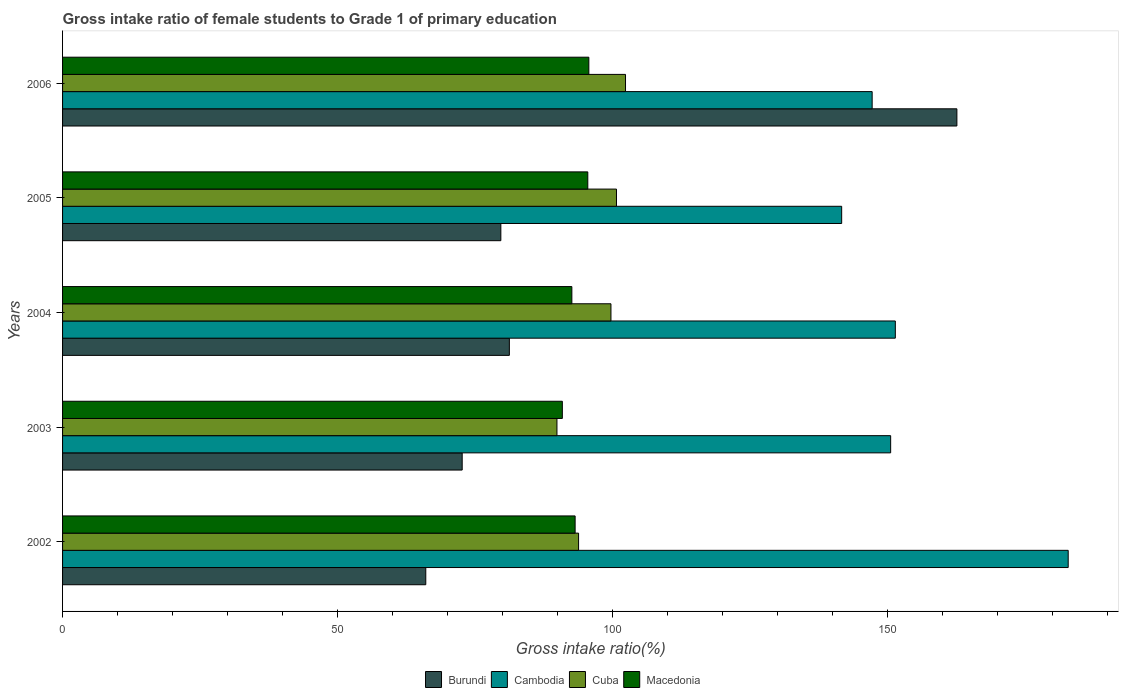How many different coloured bars are there?
Your response must be concise. 4. Are the number of bars per tick equal to the number of legend labels?
Ensure brevity in your answer.  Yes. Are the number of bars on each tick of the Y-axis equal?
Provide a succinct answer. Yes. How many bars are there on the 3rd tick from the top?
Make the answer very short. 4. In how many cases, is the number of bars for a given year not equal to the number of legend labels?
Give a very brief answer. 0. What is the gross intake ratio in Macedonia in 2004?
Keep it short and to the point. 92.58. Across all years, what is the maximum gross intake ratio in Macedonia?
Make the answer very short. 95.67. Across all years, what is the minimum gross intake ratio in Cambodia?
Ensure brevity in your answer.  141.63. In which year was the gross intake ratio in Macedonia maximum?
Give a very brief answer. 2006. What is the total gross intake ratio in Cambodia in the graph?
Ensure brevity in your answer.  773.53. What is the difference between the gross intake ratio in Cambodia in 2004 and that in 2005?
Give a very brief answer. 9.75. What is the difference between the gross intake ratio in Cambodia in 2005 and the gross intake ratio in Burundi in 2002?
Give a very brief answer. 75.6. What is the average gross intake ratio in Cambodia per year?
Offer a terse response. 154.71. In the year 2006, what is the difference between the gross intake ratio in Cuba and gross intake ratio in Macedonia?
Your answer should be very brief. 6.67. What is the ratio of the gross intake ratio in Cambodia in 2003 to that in 2006?
Your answer should be very brief. 1.02. Is the difference between the gross intake ratio in Cuba in 2004 and 2005 greater than the difference between the gross intake ratio in Macedonia in 2004 and 2005?
Offer a very short reply. Yes. What is the difference between the highest and the second highest gross intake ratio in Macedonia?
Your answer should be very brief. 0.19. What is the difference between the highest and the lowest gross intake ratio in Burundi?
Your answer should be very brief. 96.55. Is it the case that in every year, the sum of the gross intake ratio in Cambodia and gross intake ratio in Cuba is greater than the sum of gross intake ratio in Macedonia and gross intake ratio in Burundi?
Offer a very short reply. Yes. What does the 2nd bar from the top in 2006 represents?
Keep it short and to the point. Cuba. What does the 2nd bar from the bottom in 2006 represents?
Give a very brief answer. Cambodia. How many bars are there?
Your answer should be very brief. 20. How many years are there in the graph?
Provide a succinct answer. 5. Are the values on the major ticks of X-axis written in scientific E-notation?
Keep it short and to the point. No. Does the graph contain grids?
Make the answer very short. No. How are the legend labels stacked?
Make the answer very short. Horizontal. What is the title of the graph?
Keep it short and to the point. Gross intake ratio of female students to Grade 1 of primary education. Does "Macedonia" appear as one of the legend labels in the graph?
Keep it short and to the point. Yes. What is the label or title of the X-axis?
Provide a succinct answer. Gross intake ratio(%). What is the label or title of the Y-axis?
Make the answer very short. Years. What is the Gross intake ratio(%) in Burundi in 2002?
Offer a very short reply. 66.03. What is the Gross intake ratio(%) in Cambodia in 2002?
Give a very brief answer. 182.81. What is the Gross intake ratio(%) of Cuba in 2002?
Keep it short and to the point. 93.8. What is the Gross intake ratio(%) of Macedonia in 2002?
Provide a succinct answer. 93.17. What is the Gross intake ratio(%) in Burundi in 2003?
Provide a short and direct response. 72.65. What is the Gross intake ratio(%) in Cambodia in 2003?
Keep it short and to the point. 150.54. What is the Gross intake ratio(%) of Cuba in 2003?
Provide a short and direct response. 89.87. What is the Gross intake ratio(%) in Macedonia in 2003?
Your answer should be very brief. 90.85. What is the Gross intake ratio(%) of Burundi in 2004?
Your answer should be very brief. 81.22. What is the Gross intake ratio(%) in Cambodia in 2004?
Provide a short and direct response. 151.38. What is the Gross intake ratio(%) in Cuba in 2004?
Your answer should be compact. 99.69. What is the Gross intake ratio(%) in Macedonia in 2004?
Make the answer very short. 92.58. What is the Gross intake ratio(%) of Burundi in 2005?
Provide a succinct answer. 79.67. What is the Gross intake ratio(%) in Cambodia in 2005?
Offer a very short reply. 141.63. What is the Gross intake ratio(%) in Cuba in 2005?
Make the answer very short. 100.69. What is the Gross intake ratio(%) in Macedonia in 2005?
Provide a succinct answer. 95.48. What is the Gross intake ratio(%) in Burundi in 2006?
Provide a short and direct response. 162.58. What is the Gross intake ratio(%) in Cambodia in 2006?
Your response must be concise. 147.17. What is the Gross intake ratio(%) in Cuba in 2006?
Provide a succinct answer. 102.34. What is the Gross intake ratio(%) in Macedonia in 2006?
Your answer should be compact. 95.67. Across all years, what is the maximum Gross intake ratio(%) of Burundi?
Make the answer very short. 162.58. Across all years, what is the maximum Gross intake ratio(%) of Cambodia?
Keep it short and to the point. 182.81. Across all years, what is the maximum Gross intake ratio(%) of Cuba?
Provide a short and direct response. 102.34. Across all years, what is the maximum Gross intake ratio(%) in Macedonia?
Offer a terse response. 95.67. Across all years, what is the minimum Gross intake ratio(%) in Burundi?
Your answer should be compact. 66.03. Across all years, what is the minimum Gross intake ratio(%) of Cambodia?
Keep it short and to the point. 141.63. Across all years, what is the minimum Gross intake ratio(%) in Cuba?
Provide a short and direct response. 89.87. Across all years, what is the minimum Gross intake ratio(%) in Macedonia?
Keep it short and to the point. 90.85. What is the total Gross intake ratio(%) in Burundi in the graph?
Your response must be concise. 462.14. What is the total Gross intake ratio(%) of Cambodia in the graph?
Keep it short and to the point. 773.53. What is the total Gross intake ratio(%) of Cuba in the graph?
Your answer should be compact. 486.4. What is the total Gross intake ratio(%) of Macedonia in the graph?
Keep it short and to the point. 467.76. What is the difference between the Gross intake ratio(%) in Burundi in 2002 and that in 2003?
Your answer should be very brief. -6.62. What is the difference between the Gross intake ratio(%) of Cambodia in 2002 and that in 2003?
Ensure brevity in your answer.  32.28. What is the difference between the Gross intake ratio(%) in Cuba in 2002 and that in 2003?
Your answer should be very brief. 3.93. What is the difference between the Gross intake ratio(%) of Macedonia in 2002 and that in 2003?
Your response must be concise. 2.32. What is the difference between the Gross intake ratio(%) in Burundi in 2002 and that in 2004?
Offer a terse response. -15.19. What is the difference between the Gross intake ratio(%) of Cambodia in 2002 and that in 2004?
Provide a short and direct response. 31.43. What is the difference between the Gross intake ratio(%) in Cuba in 2002 and that in 2004?
Provide a succinct answer. -5.89. What is the difference between the Gross intake ratio(%) in Macedonia in 2002 and that in 2004?
Give a very brief answer. 0.59. What is the difference between the Gross intake ratio(%) in Burundi in 2002 and that in 2005?
Make the answer very short. -13.65. What is the difference between the Gross intake ratio(%) in Cambodia in 2002 and that in 2005?
Your answer should be compact. 41.18. What is the difference between the Gross intake ratio(%) of Cuba in 2002 and that in 2005?
Keep it short and to the point. -6.89. What is the difference between the Gross intake ratio(%) of Macedonia in 2002 and that in 2005?
Provide a short and direct response. -2.3. What is the difference between the Gross intake ratio(%) of Burundi in 2002 and that in 2006?
Make the answer very short. -96.55. What is the difference between the Gross intake ratio(%) in Cambodia in 2002 and that in 2006?
Provide a succinct answer. 35.64. What is the difference between the Gross intake ratio(%) of Cuba in 2002 and that in 2006?
Offer a terse response. -8.53. What is the difference between the Gross intake ratio(%) in Macedonia in 2002 and that in 2006?
Make the answer very short. -2.5. What is the difference between the Gross intake ratio(%) of Burundi in 2003 and that in 2004?
Your response must be concise. -8.57. What is the difference between the Gross intake ratio(%) of Cambodia in 2003 and that in 2004?
Your answer should be compact. -0.85. What is the difference between the Gross intake ratio(%) of Cuba in 2003 and that in 2004?
Keep it short and to the point. -9.82. What is the difference between the Gross intake ratio(%) of Macedonia in 2003 and that in 2004?
Ensure brevity in your answer.  -1.73. What is the difference between the Gross intake ratio(%) of Burundi in 2003 and that in 2005?
Provide a short and direct response. -7.03. What is the difference between the Gross intake ratio(%) of Cambodia in 2003 and that in 2005?
Provide a short and direct response. 8.9. What is the difference between the Gross intake ratio(%) in Cuba in 2003 and that in 2005?
Give a very brief answer. -10.82. What is the difference between the Gross intake ratio(%) in Macedonia in 2003 and that in 2005?
Provide a succinct answer. -4.63. What is the difference between the Gross intake ratio(%) of Burundi in 2003 and that in 2006?
Make the answer very short. -89.93. What is the difference between the Gross intake ratio(%) of Cambodia in 2003 and that in 2006?
Give a very brief answer. 3.36. What is the difference between the Gross intake ratio(%) of Cuba in 2003 and that in 2006?
Your answer should be compact. -12.46. What is the difference between the Gross intake ratio(%) in Macedonia in 2003 and that in 2006?
Offer a terse response. -4.82. What is the difference between the Gross intake ratio(%) of Burundi in 2004 and that in 2005?
Provide a succinct answer. 1.55. What is the difference between the Gross intake ratio(%) in Cambodia in 2004 and that in 2005?
Give a very brief answer. 9.75. What is the difference between the Gross intake ratio(%) in Cuba in 2004 and that in 2005?
Give a very brief answer. -1. What is the difference between the Gross intake ratio(%) of Macedonia in 2004 and that in 2005?
Keep it short and to the point. -2.9. What is the difference between the Gross intake ratio(%) of Burundi in 2004 and that in 2006?
Keep it short and to the point. -81.36. What is the difference between the Gross intake ratio(%) in Cambodia in 2004 and that in 2006?
Ensure brevity in your answer.  4.21. What is the difference between the Gross intake ratio(%) in Cuba in 2004 and that in 2006?
Keep it short and to the point. -2.65. What is the difference between the Gross intake ratio(%) of Macedonia in 2004 and that in 2006?
Your answer should be compact. -3.09. What is the difference between the Gross intake ratio(%) of Burundi in 2005 and that in 2006?
Provide a succinct answer. -82.9. What is the difference between the Gross intake ratio(%) of Cambodia in 2005 and that in 2006?
Offer a very short reply. -5.54. What is the difference between the Gross intake ratio(%) in Cuba in 2005 and that in 2006?
Your response must be concise. -1.64. What is the difference between the Gross intake ratio(%) in Macedonia in 2005 and that in 2006?
Ensure brevity in your answer.  -0.19. What is the difference between the Gross intake ratio(%) of Burundi in 2002 and the Gross intake ratio(%) of Cambodia in 2003?
Provide a succinct answer. -84.51. What is the difference between the Gross intake ratio(%) in Burundi in 2002 and the Gross intake ratio(%) in Cuba in 2003?
Your response must be concise. -23.85. What is the difference between the Gross intake ratio(%) of Burundi in 2002 and the Gross intake ratio(%) of Macedonia in 2003?
Offer a terse response. -24.83. What is the difference between the Gross intake ratio(%) in Cambodia in 2002 and the Gross intake ratio(%) in Cuba in 2003?
Your answer should be compact. 92.94. What is the difference between the Gross intake ratio(%) in Cambodia in 2002 and the Gross intake ratio(%) in Macedonia in 2003?
Your response must be concise. 91.96. What is the difference between the Gross intake ratio(%) in Cuba in 2002 and the Gross intake ratio(%) in Macedonia in 2003?
Your answer should be compact. 2.95. What is the difference between the Gross intake ratio(%) of Burundi in 2002 and the Gross intake ratio(%) of Cambodia in 2004?
Provide a short and direct response. -85.36. What is the difference between the Gross intake ratio(%) of Burundi in 2002 and the Gross intake ratio(%) of Cuba in 2004?
Provide a succinct answer. -33.66. What is the difference between the Gross intake ratio(%) of Burundi in 2002 and the Gross intake ratio(%) of Macedonia in 2004?
Make the answer very short. -26.55. What is the difference between the Gross intake ratio(%) of Cambodia in 2002 and the Gross intake ratio(%) of Cuba in 2004?
Offer a very short reply. 83.12. What is the difference between the Gross intake ratio(%) of Cambodia in 2002 and the Gross intake ratio(%) of Macedonia in 2004?
Provide a succinct answer. 90.23. What is the difference between the Gross intake ratio(%) in Cuba in 2002 and the Gross intake ratio(%) in Macedonia in 2004?
Offer a terse response. 1.22. What is the difference between the Gross intake ratio(%) in Burundi in 2002 and the Gross intake ratio(%) in Cambodia in 2005?
Provide a succinct answer. -75.6. What is the difference between the Gross intake ratio(%) in Burundi in 2002 and the Gross intake ratio(%) in Cuba in 2005?
Keep it short and to the point. -34.67. What is the difference between the Gross intake ratio(%) of Burundi in 2002 and the Gross intake ratio(%) of Macedonia in 2005?
Give a very brief answer. -29.45. What is the difference between the Gross intake ratio(%) in Cambodia in 2002 and the Gross intake ratio(%) in Cuba in 2005?
Your response must be concise. 82.12. What is the difference between the Gross intake ratio(%) of Cambodia in 2002 and the Gross intake ratio(%) of Macedonia in 2005?
Your response must be concise. 87.33. What is the difference between the Gross intake ratio(%) of Cuba in 2002 and the Gross intake ratio(%) of Macedonia in 2005?
Keep it short and to the point. -1.67. What is the difference between the Gross intake ratio(%) of Burundi in 2002 and the Gross intake ratio(%) of Cambodia in 2006?
Give a very brief answer. -81.15. What is the difference between the Gross intake ratio(%) in Burundi in 2002 and the Gross intake ratio(%) in Cuba in 2006?
Make the answer very short. -36.31. What is the difference between the Gross intake ratio(%) in Burundi in 2002 and the Gross intake ratio(%) in Macedonia in 2006?
Provide a short and direct response. -29.64. What is the difference between the Gross intake ratio(%) in Cambodia in 2002 and the Gross intake ratio(%) in Cuba in 2006?
Provide a succinct answer. 80.47. What is the difference between the Gross intake ratio(%) of Cambodia in 2002 and the Gross intake ratio(%) of Macedonia in 2006?
Your response must be concise. 87.14. What is the difference between the Gross intake ratio(%) of Cuba in 2002 and the Gross intake ratio(%) of Macedonia in 2006?
Keep it short and to the point. -1.87. What is the difference between the Gross intake ratio(%) in Burundi in 2003 and the Gross intake ratio(%) in Cambodia in 2004?
Offer a very short reply. -78.74. What is the difference between the Gross intake ratio(%) in Burundi in 2003 and the Gross intake ratio(%) in Cuba in 2004?
Make the answer very short. -27.04. What is the difference between the Gross intake ratio(%) in Burundi in 2003 and the Gross intake ratio(%) in Macedonia in 2004?
Keep it short and to the point. -19.94. What is the difference between the Gross intake ratio(%) of Cambodia in 2003 and the Gross intake ratio(%) of Cuba in 2004?
Give a very brief answer. 50.85. What is the difference between the Gross intake ratio(%) of Cambodia in 2003 and the Gross intake ratio(%) of Macedonia in 2004?
Give a very brief answer. 57.96. What is the difference between the Gross intake ratio(%) in Cuba in 2003 and the Gross intake ratio(%) in Macedonia in 2004?
Your response must be concise. -2.71. What is the difference between the Gross intake ratio(%) of Burundi in 2003 and the Gross intake ratio(%) of Cambodia in 2005?
Offer a terse response. -68.99. What is the difference between the Gross intake ratio(%) of Burundi in 2003 and the Gross intake ratio(%) of Cuba in 2005?
Offer a very short reply. -28.05. What is the difference between the Gross intake ratio(%) of Burundi in 2003 and the Gross intake ratio(%) of Macedonia in 2005?
Offer a terse response. -22.83. What is the difference between the Gross intake ratio(%) in Cambodia in 2003 and the Gross intake ratio(%) in Cuba in 2005?
Ensure brevity in your answer.  49.84. What is the difference between the Gross intake ratio(%) in Cambodia in 2003 and the Gross intake ratio(%) in Macedonia in 2005?
Offer a very short reply. 55.06. What is the difference between the Gross intake ratio(%) in Cuba in 2003 and the Gross intake ratio(%) in Macedonia in 2005?
Your answer should be very brief. -5.61. What is the difference between the Gross intake ratio(%) of Burundi in 2003 and the Gross intake ratio(%) of Cambodia in 2006?
Provide a short and direct response. -74.53. What is the difference between the Gross intake ratio(%) of Burundi in 2003 and the Gross intake ratio(%) of Cuba in 2006?
Provide a succinct answer. -29.69. What is the difference between the Gross intake ratio(%) in Burundi in 2003 and the Gross intake ratio(%) in Macedonia in 2006?
Your answer should be very brief. -23.02. What is the difference between the Gross intake ratio(%) of Cambodia in 2003 and the Gross intake ratio(%) of Cuba in 2006?
Your response must be concise. 48.2. What is the difference between the Gross intake ratio(%) in Cambodia in 2003 and the Gross intake ratio(%) in Macedonia in 2006?
Offer a very short reply. 54.87. What is the difference between the Gross intake ratio(%) in Cuba in 2003 and the Gross intake ratio(%) in Macedonia in 2006?
Your response must be concise. -5.8. What is the difference between the Gross intake ratio(%) in Burundi in 2004 and the Gross intake ratio(%) in Cambodia in 2005?
Your answer should be compact. -60.41. What is the difference between the Gross intake ratio(%) in Burundi in 2004 and the Gross intake ratio(%) in Cuba in 2005?
Give a very brief answer. -19.48. What is the difference between the Gross intake ratio(%) in Burundi in 2004 and the Gross intake ratio(%) in Macedonia in 2005?
Offer a terse response. -14.26. What is the difference between the Gross intake ratio(%) of Cambodia in 2004 and the Gross intake ratio(%) of Cuba in 2005?
Give a very brief answer. 50.69. What is the difference between the Gross intake ratio(%) of Cambodia in 2004 and the Gross intake ratio(%) of Macedonia in 2005?
Offer a very short reply. 55.9. What is the difference between the Gross intake ratio(%) in Cuba in 2004 and the Gross intake ratio(%) in Macedonia in 2005?
Offer a terse response. 4.21. What is the difference between the Gross intake ratio(%) in Burundi in 2004 and the Gross intake ratio(%) in Cambodia in 2006?
Give a very brief answer. -65.95. What is the difference between the Gross intake ratio(%) of Burundi in 2004 and the Gross intake ratio(%) of Cuba in 2006?
Your answer should be compact. -21.12. What is the difference between the Gross intake ratio(%) in Burundi in 2004 and the Gross intake ratio(%) in Macedonia in 2006?
Offer a very short reply. -14.45. What is the difference between the Gross intake ratio(%) of Cambodia in 2004 and the Gross intake ratio(%) of Cuba in 2006?
Keep it short and to the point. 49.05. What is the difference between the Gross intake ratio(%) in Cambodia in 2004 and the Gross intake ratio(%) in Macedonia in 2006?
Your response must be concise. 55.71. What is the difference between the Gross intake ratio(%) of Cuba in 2004 and the Gross intake ratio(%) of Macedonia in 2006?
Ensure brevity in your answer.  4.02. What is the difference between the Gross intake ratio(%) of Burundi in 2005 and the Gross intake ratio(%) of Cambodia in 2006?
Provide a short and direct response. -67.5. What is the difference between the Gross intake ratio(%) of Burundi in 2005 and the Gross intake ratio(%) of Cuba in 2006?
Give a very brief answer. -22.66. What is the difference between the Gross intake ratio(%) in Burundi in 2005 and the Gross intake ratio(%) in Macedonia in 2006?
Offer a terse response. -16. What is the difference between the Gross intake ratio(%) in Cambodia in 2005 and the Gross intake ratio(%) in Cuba in 2006?
Give a very brief answer. 39.29. What is the difference between the Gross intake ratio(%) of Cambodia in 2005 and the Gross intake ratio(%) of Macedonia in 2006?
Give a very brief answer. 45.96. What is the difference between the Gross intake ratio(%) in Cuba in 2005 and the Gross intake ratio(%) in Macedonia in 2006?
Offer a very short reply. 5.02. What is the average Gross intake ratio(%) in Burundi per year?
Offer a very short reply. 92.43. What is the average Gross intake ratio(%) of Cambodia per year?
Your answer should be very brief. 154.71. What is the average Gross intake ratio(%) in Cuba per year?
Keep it short and to the point. 97.28. What is the average Gross intake ratio(%) in Macedonia per year?
Give a very brief answer. 93.55. In the year 2002, what is the difference between the Gross intake ratio(%) in Burundi and Gross intake ratio(%) in Cambodia?
Your answer should be compact. -116.78. In the year 2002, what is the difference between the Gross intake ratio(%) of Burundi and Gross intake ratio(%) of Cuba?
Provide a short and direct response. -27.78. In the year 2002, what is the difference between the Gross intake ratio(%) in Burundi and Gross intake ratio(%) in Macedonia?
Keep it short and to the point. -27.15. In the year 2002, what is the difference between the Gross intake ratio(%) in Cambodia and Gross intake ratio(%) in Cuba?
Ensure brevity in your answer.  89.01. In the year 2002, what is the difference between the Gross intake ratio(%) in Cambodia and Gross intake ratio(%) in Macedonia?
Provide a short and direct response. 89.64. In the year 2002, what is the difference between the Gross intake ratio(%) in Cuba and Gross intake ratio(%) in Macedonia?
Ensure brevity in your answer.  0.63. In the year 2003, what is the difference between the Gross intake ratio(%) of Burundi and Gross intake ratio(%) of Cambodia?
Keep it short and to the point. -77.89. In the year 2003, what is the difference between the Gross intake ratio(%) of Burundi and Gross intake ratio(%) of Cuba?
Make the answer very short. -17.23. In the year 2003, what is the difference between the Gross intake ratio(%) in Burundi and Gross intake ratio(%) in Macedonia?
Provide a short and direct response. -18.21. In the year 2003, what is the difference between the Gross intake ratio(%) of Cambodia and Gross intake ratio(%) of Cuba?
Give a very brief answer. 60.66. In the year 2003, what is the difference between the Gross intake ratio(%) of Cambodia and Gross intake ratio(%) of Macedonia?
Keep it short and to the point. 59.68. In the year 2003, what is the difference between the Gross intake ratio(%) of Cuba and Gross intake ratio(%) of Macedonia?
Keep it short and to the point. -0.98. In the year 2004, what is the difference between the Gross intake ratio(%) in Burundi and Gross intake ratio(%) in Cambodia?
Offer a very short reply. -70.16. In the year 2004, what is the difference between the Gross intake ratio(%) in Burundi and Gross intake ratio(%) in Cuba?
Give a very brief answer. -18.47. In the year 2004, what is the difference between the Gross intake ratio(%) of Burundi and Gross intake ratio(%) of Macedonia?
Your response must be concise. -11.36. In the year 2004, what is the difference between the Gross intake ratio(%) in Cambodia and Gross intake ratio(%) in Cuba?
Ensure brevity in your answer.  51.69. In the year 2004, what is the difference between the Gross intake ratio(%) in Cambodia and Gross intake ratio(%) in Macedonia?
Your answer should be very brief. 58.8. In the year 2004, what is the difference between the Gross intake ratio(%) in Cuba and Gross intake ratio(%) in Macedonia?
Provide a succinct answer. 7.11. In the year 2005, what is the difference between the Gross intake ratio(%) of Burundi and Gross intake ratio(%) of Cambodia?
Offer a very short reply. -61.96. In the year 2005, what is the difference between the Gross intake ratio(%) of Burundi and Gross intake ratio(%) of Cuba?
Ensure brevity in your answer.  -21.02. In the year 2005, what is the difference between the Gross intake ratio(%) of Burundi and Gross intake ratio(%) of Macedonia?
Your response must be concise. -15.81. In the year 2005, what is the difference between the Gross intake ratio(%) in Cambodia and Gross intake ratio(%) in Cuba?
Offer a terse response. 40.94. In the year 2005, what is the difference between the Gross intake ratio(%) of Cambodia and Gross intake ratio(%) of Macedonia?
Your answer should be compact. 46.15. In the year 2005, what is the difference between the Gross intake ratio(%) in Cuba and Gross intake ratio(%) in Macedonia?
Make the answer very short. 5.22. In the year 2006, what is the difference between the Gross intake ratio(%) in Burundi and Gross intake ratio(%) in Cambodia?
Provide a succinct answer. 15.4. In the year 2006, what is the difference between the Gross intake ratio(%) in Burundi and Gross intake ratio(%) in Cuba?
Keep it short and to the point. 60.24. In the year 2006, what is the difference between the Gross intake ratio(%) in Burundi and Gross intake ratio(%) in Macedonia?
Offer a terse response. 66.91. In the year 2006, what is the difference between the Gross intake ratio(%) of Cambodia and Gross intake ratio(%) of Cuba?
Your answer should be compact. 44.83. In the year 2006, what is the difference between the Gross intake ratio(%) in Cambodia and Gross intake ratio(%) in Macedonia?
Your answer should be very brief. 51.5. In the year 2006, what is the difference between the Gross intake ratio(%) in Cuba and Gross intake ratio(%) in Macedonia?
Offer a very short reply. 6.67. What is the ratio of the Gross intake ratio(%) in Burundi in 2002 to that in 2003?
Make the answer very short. 0.91. What is the ratio of the Gross intake ratio(%) of Cambodia in 2002 to that in 2003?
Ensure brevity in your answer.  1.21. What is the ratio of the Gross intake ratio(%) of Cuba in 2002 to that in 2003?
Provide a short and direct response. 1.04. What is the ratio of the Gross intake ratio(%) in Macedonia in 2002 to that in 2003?
Offer a terse response. 1.03. What is the ratio of the Gross intake ratio(%) of Burundi in 2002 to that in 2004?
Provide a succinct answer. 0.81. What is the ratio of the Gross intake ratio(%) in Cambodia in 2002 to that in 2004?
Your response must be concise. 1.21. What is the ratio of the Gross intake ratio(%) of Cuba in 2002 to that in 2004?
Make the answer very short. 0.94. What is the ratio of the Gross intake ratio(%) in Macedonia in 2002 to that in 2004?
Offer a very short reply. 1.01. What is the ratio of the Gross intake ratio(%) of Burundi in 2002 to that in 2005?
Your answer should be compact. 0.83. What is the ratio of the Gross intake ratio(%) in Cambodia in 2002 to that in 2005?
Provide a short and direct response. 1.29. What is the ratio of the Gross intake ratio(%) in Cuba in 2002 to that in 2005?
Ensure brevity in your answer.  0.93. What is the ratio of the Gross intake ratio(%) in Macedonia in 2002 to that in 2005?
Offer a terse response. 0.98. What is the ratio of the Gross intake ratio(%) of Burundi in 2002 to that in 2006?
Your answer should be compact. 0.41. What is the ratio of the Gross intake ratio(%) of Cambodia in 2002 to that in 2006?
Your response must be concise. 1.24. What is the ratio of the Gross intake ratio(%) of Cuba in 2002 to that in 2006?
Keep it short and to the point. 0.92. What is the ratio of the Gross intake ratio(%) in Macedonia in 2002 to that in 2006?
Offer a very short reply. 0.97. What is the ratio of the Gross intake ratio(%) of Burundi in 2003 to that in 2004?
Your answer should be very brief. 0.89. What is the ratio of the Gross intake ratio(%) of Cuba in 2003 to that in 2004?
Offer a very short reply. 0.9. What is the ratio of the Gross intake ratio(%) in Macedonia in 2003 to that in 2004?
Your response must be concise. 0.98. What is the ratio of the Gross intake ratio(%) of Burundi in 2003 to that in 2005?
Provide a short and direct response. 0.91. What is the ratio of the Gross intake ratio(%) of Cambodia in 2003 to that in 2005?
Make the answer very short. 1.06. What is the ratio of the Gross intake ratio(%) of Cuba in 2003 to that in 2005?
Keep it short and to the point. 0.89. What is the ratio of the Gross intake ratio(%) of Macedonia in 2003 to that in 2005?
Keep it short and to the point. 0.95. What is the ratio of the Gross intake ratio(%) of Burundi in 2003 to that in 2006?
Provide a succinct answer. 0.45. What is the ratio of the Gross intake ratio(%) in Cambodia in 2003 to that in 2006?
Make the answer very short. 1.02. What is the ratio of the Gross intake ratio(%) of Cuba in 2003 to that in 2006?
Your response must be concise. 0.88. What is the ratio of the Gross intake ratio(%) in Macedonia in 2003 to that in 2006?
Ensure brevity in your answer.  0.95. What is the ratio of the Gross intake ratio(%) of Burundi in 2004 to that in 2005?
Offer a terse response. 1.02. What is the ratio of the Gross intake ratio(%) in Cambodia in 2004 to that in 2005?
Provide a succinct answer. 1.07. What is the ratio of the Gross intake ratio(%) of Macedonia in 2004 to that in 2005?
Provide a succinct answer. 0.97. What is the ratio of the Gross intake ratio(%) of Burundi in 2004 to that in 2006?
Your answer should be very brief. 0.5. What is the ratio of the Gross intake ratio(%) of Cambodia in 2004 to that in 2006?
Your answer should be very brief. 1.03. What is the ratio of the Gross intake ratio(%) of Cuba in 2004 to that in 2006?
Provide a short and direct response. 0.97. What is the ratio of the Gross intake ratio(%) of Burundi in 2005 to that in 2006?
Your response must be concise. 0.49. What is the ratio of the Gross intake ratio(%) in Cambodia in 2005 to that in 2006?
Your response must be concise. 0.96. What is the ratio of the Gross intake ratio(%) in Cuba in 2005 to that in 2006?
Make the answer very short. 0.98. What is the ratio of the Gross intake ratio(%) in Macedonia in 2005 to that in 2006?
Offer a terse response. 1. What is the difference between the highest and the second highest Gross intake ratio(%) of Burundi?
Provide a succinct answer. 81.36. What is the difference between the highest and the second highest Gross intake ratio(%) in Cambodia?
Make the answer very short. 31.43. What is the difference between the highest and the second highest Gross intake ratio(%) of Cuba?
Offer a very short reply. 1.64. What is the difference between the highest and the second highest Gross intake ratio(%) of Macedonia?
Provide a succinct answer. 0.19. What is the difference between the highest and the lowest Gross intake ratio(%) of Burundi?
Provide a short and direct response. 96.55. What is the difference between the highest and the lowest Gross intake ratio(%) of Cambodia?
Make the answer very short. 41.18. What is the difference between the highest and the lowest Gross intake ratio(%) in Cuba?
Offer a very short reply. 12.46. What is the difference between the highest and the lowest Gross intake ratio(%) of Macedonia?
Your response must be concise. 4.82. 